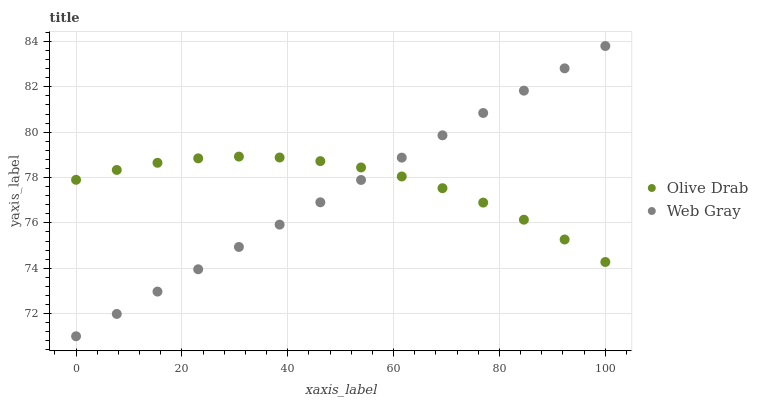Does Web Gray have the minimum area under the curve?
Answer yes or no. Yes. Does Olive Drab have the maximum area under the curve?
Answer yes or no. Yes. Does Olive Drab have the minimum area under the curve?
Answer yes or no. No. Is Web Gray the smoothest?
Answer yes or no. Yes. Is Olive Drab the roughest?
Answer yes or no. Yes. Is Olive Drab the smoothest?
Answer yes or no. No. Does Web Gray have the lowest value?
Answer yes or no. Yes. Does Olive Drab have the lowest value?
Answer yes or no. No. Does Web Gray have the highest value?
Answer yes or no. Yes. Does Olive Drab have the highest value?
Answer yes or no. No. Does Olive Drab intersect Web Gray?
Answer yes or no. Yes. Is Olive Drab less than Web Gray?
Answer yes or no. No. Is Olive Drab greater than Web Gray?
Answer yes or no. No. 